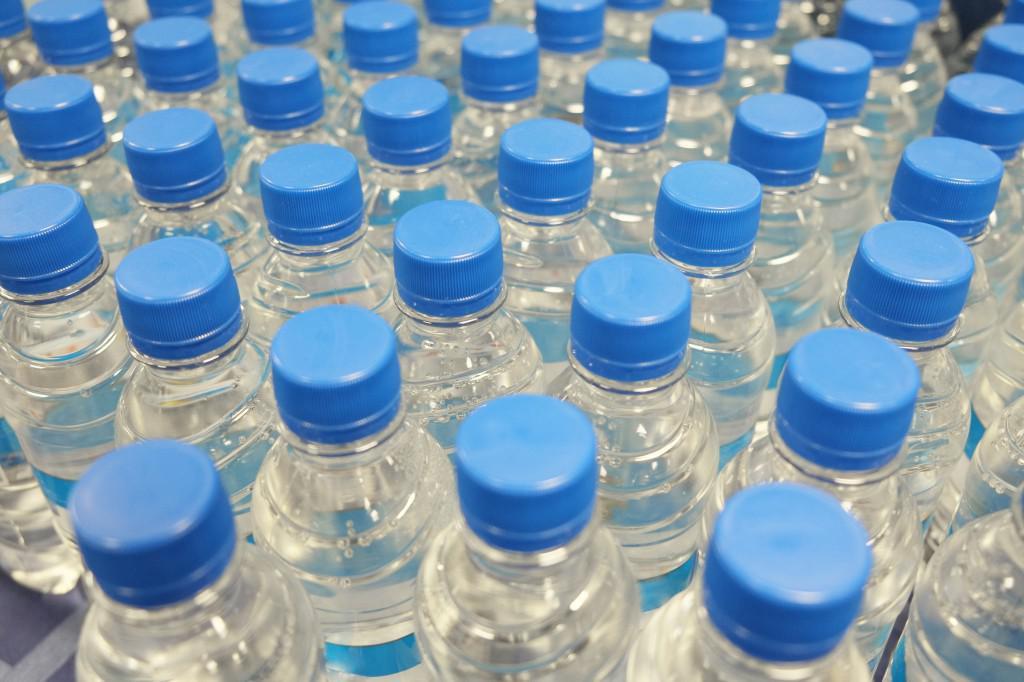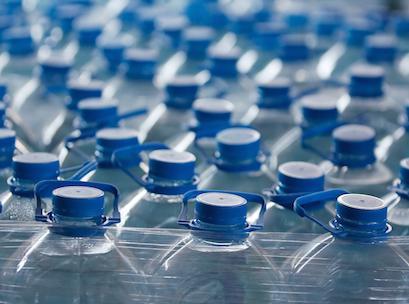The first image is the image on the left, the second image is the image on the right. Examine the images to the left and right. Is the description "the white capped bottles in the image on the right are sealed in packages of at least 16" accurate? Answer yes or no. No. The first image is the image on the left, the second image is the image on the right. Evaluate the accuracy of this statement regarding the images: "At least one image shows stacked plastic-wrapped bundles of bottles.". Is it true? Answer yes or no. No. 